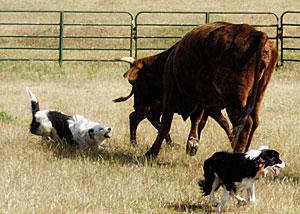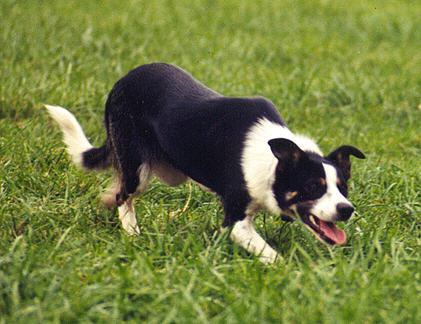The first image is the image on the left, the second image is the image on the right. For the images shown, is this caption "At least one image features only a black and white dog, with no livestock." true? Answer yes or no. Yes. The first image is the image on the left, the second image is the image on the right. For the images shown, is this caption "The right image shows only one animal." true? Answer yes or no. Yes. 